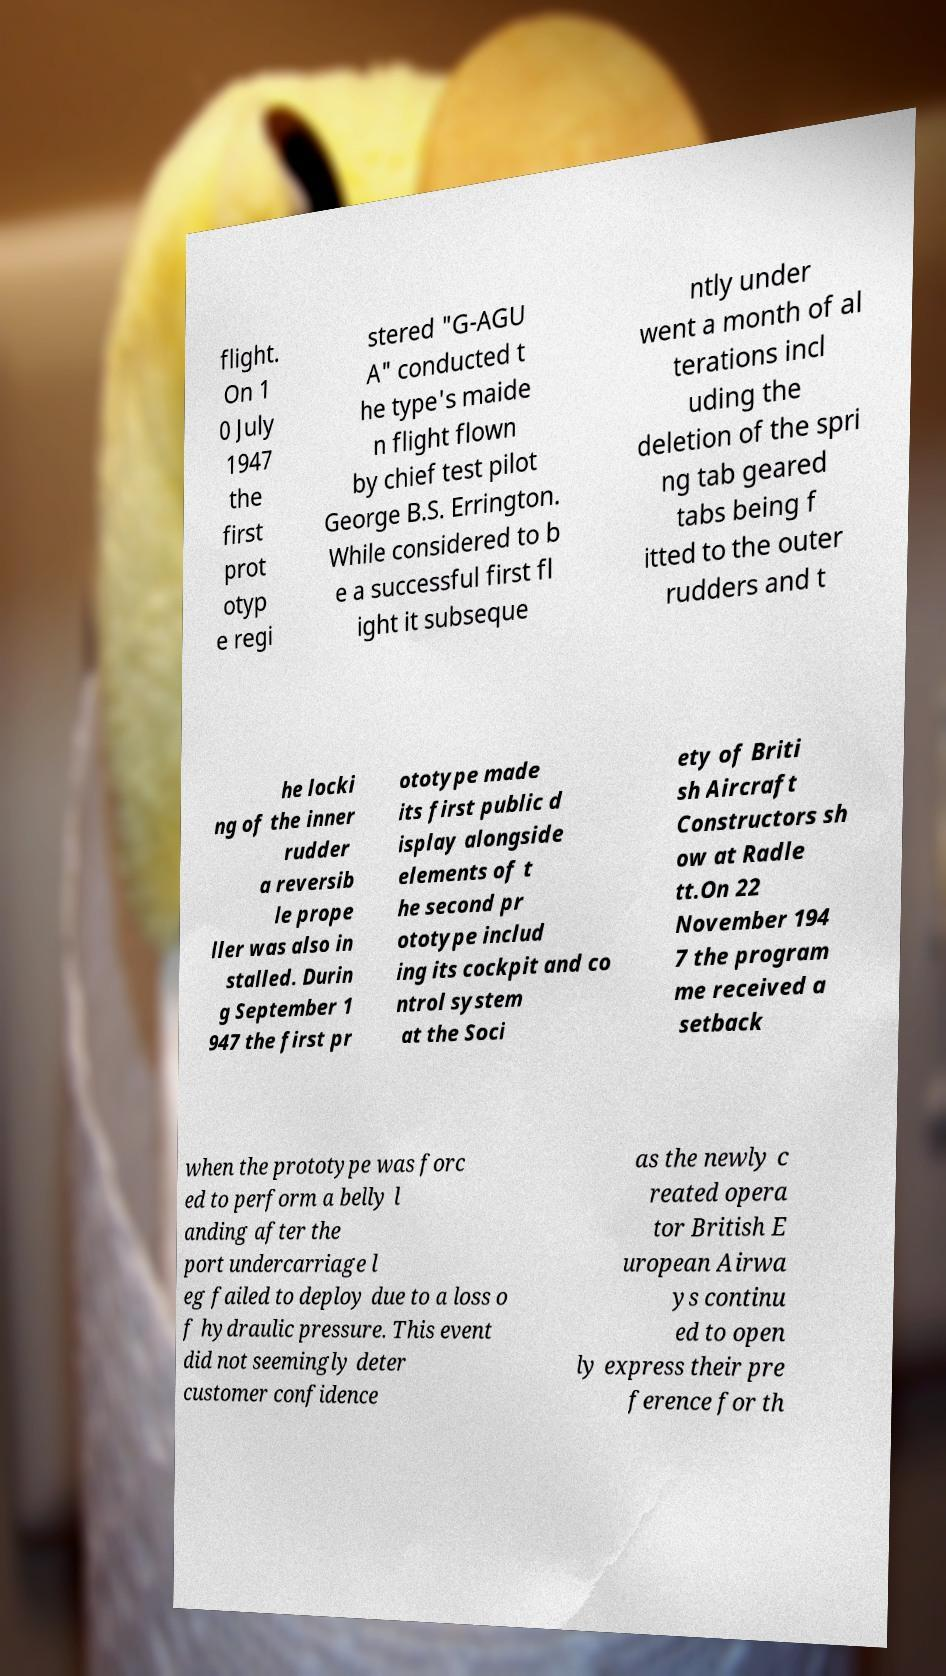Can you accurately transcribe the text from the provided image for me? flight. On 1 0 July 1947 the first prot otyp e regi stered "G-AGU A" conducted t he type's maide n flight flown by chief test pilot George B.S. Errington. While considered to b e a successful first fl ight it subseque ntly under went a month of al terations incl uding the deletion of the spri ng tab geared tabs being f itted to the outer rudders and t he locki ng of the inner rudder a reversib le prope ller was also in stalled. Durin g September 1 947 the first pr ototype made its first public d isplay alongside elements of t he second pr ototype includ ing its cockpit and co ntrol system at the Soci ety of Briti sh Aircraft Constructors sh ow at Radle tt.On 22 November 194 7 the program me received a setback when the prototype was forc ed to perform a belly l anding after the port undercarriage l eg failed to deploy due to a loss o f hydraulic pressure. This event did not seemingly deter customer confidence as the newly c reated opera tor British E uropean Airwa ys continu ed to open ly express their pre ference for th 